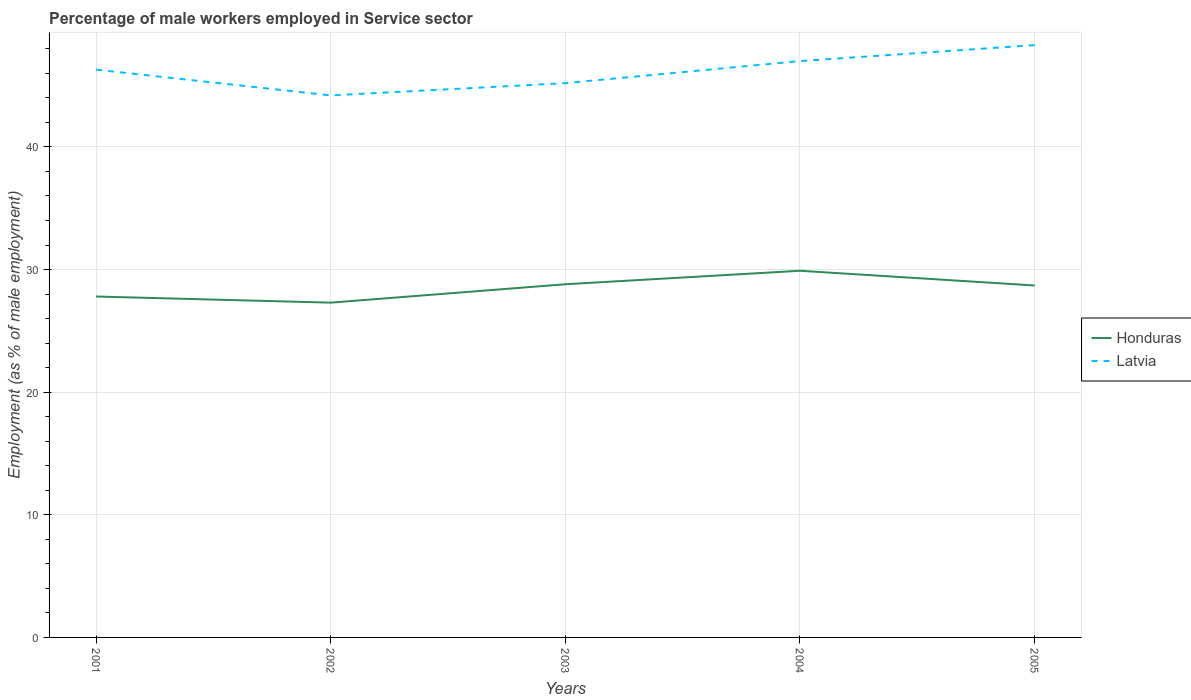How many different coloured lines are there?
Your answer should be compact. 2. Does the line corresponding to Honduras intersect with the line corresponding to Latvia?
Give a very brief answer. No. Is the number of lines equal to the number of legend labels?
Provide a short and direct response. Yes. Across all years, what is the maximum percentage of male workers employed in Service sector in Honduras?
Offer a very short reply. 27.3. In which year was the percentage of male workers employed in Service sector in Latvia maximum?
Your answer should be very brief. 2002. What is the total percentage of male workers employed in Service sector in Latvia in the graph?
Your answer should be compact. 1.1. What is the difference between the highest and the second highest percentage of male workers employed in Service sector in Honduras?
Make the answer very short. 2.6. Is the percentage of male workers employed in Service sector in Honduras strictly greater than the percentage of male workers employed in Service sector in Latvia over the years?
Your answer should be compact. Yes. How many lines are there?
Your answer should be compact. 2. How many years are there in the graph?
Offer a terse response. 5. Are the values on the major ticks of Y-axis written in scientific E-notation?
Your response must be concise. No. Does the graph contain grids?
Your answer should be very brief. Yes. What is the title of the graph?
Give a very brief answer. Percentage of male workers employed in Service sector. Does "Aruba" appear as one of the legend labels in the graph?
Provide a succinct answer. No. What is the label or title of the Y-axis?
Give a very brief answer. Employment (as % of male employment). What is the Employment (as % of male employment) in Honduras in 2001?
Offer a very short reply. 27.8. What is the Employment (as % of male employment) in Latvia in 2001?
Provide a short and direct response. 46.3. What is the Employment (as % of male employment) in Honduras in 2002?
Your answer should be very brief. 27.3. What is the Employment (as % of male employment) in Latvia in 2002?
Make the answer very short. 44.2. What is the Employment (as % of male employment) of Honduras in 2003?
Make the answer very short. 28.8. What is the Employment (as % of male employment) in Latvia in 2003?
Give a very brief answer. 45.2. What is the Employment (as % of male employment) of Honduras in 2004?
Your answer should be very brief. 29.9. What is the Employment (as % of male employment) of Latvia in 2004?
Keep it short and to the point. 47. What is the Employment (as % of male employment) in Honduras in 2005?
Your answer should be very brief. 28.7. What is the Employment (as % of male employment) of Latvia in 2005?
Your response must be concise. 48.3. Across all years, what is the maximum Employment (as % of male employment) in Honduras?
Keep it short and to the point. 29.9. Across all years, what is the maximum Employment (as % of male employment) in Latvia?
Your response must be concise. 48.3. Across all years, what is the minimum Employment (as % of male employment) of Honduras?
Ensure brevity in your answer.  27.3. Across all years, what is the minimum Employment (as % of male employment) of Latvia?
Offer a very short reply. 44.2. What is the total Employment (as % of male employment) in Honduras in the graph?
Make the answer very short. 142.5. What is the total Employment (as % of male employment) of Latvia in the graph?
Provide a succinct answer. 231. What is the difference between the Employment (as % of male employment) in Honduras in 2001 and that in 2002?
Make the answer very short. 0.5. What is the difference between the Employment (as % of male employment) of Latvia in 2001 and that in 2002?
Provide a succinct answer. 2.1. What is the difference between the Employment (as % of male employment) in Honduras in 2001 and that in 2005?
Your response must be concise. -0.9. What is the difference between the Employment (as % of male employment) in Honduras in 2002 and that in 2003?
Give a very brief answer. -1.5. What is the difference between the Employment (as % of male employment) of Latvia in 2002 and that in 2003?
Make the answer very short. -1. What is the difference between the Employment (as % of male employment) of Latvia in 2002 and that in 2004?
Keep it short and to the point. -2.8. What is the difference between the Employment (as % of male employment) of Latvia in 2002 and that in 2005?
Your response must be concise. -4.1. What is the difference between the Employment (as % of male employment) in Honduras in 2003 and that in 2004?
Offer a very short reply. -1.1. What is the difference between the Employment (as % of male employment) of Honduras in 2003 and that in 2005?
Make the answer very short. 0.1. What is the difference between the Employment (as % of male employment) of Honduras in 2004 and that in 2005?
Provide a short and direct response. 1.2. What is the difference between the Employment (as % of male employment) of Latvia in 2004 and that in 2005?
Give a very brief answer. -1.3. What is the difference between the Employment (as % of male employment) in Honduras in 2001 and the Employment (as % of male employment) in Latvia in 2002?
Provide a short and direct response. -16.4. What is the difference between the Employment (as % of male employment) in Honduras in 2001 and the Employment (as % of male employment) in Latvia in 2003?
Your response must be concise. -17.4. What is the difference between the Employment (as % of male employment) of Honduras in 2001 and the Employment (as % of male employment) of Latvia in 2004?
Provide a short and direct response. -19.2. What is the difference between the Employment (as % of male employment) in Honduras in 2001 and the Employment (as % of male employment) in Latvia in 2005?
Ensure brevity in your answer.  -20.5. What is the difference between the Employment (as % of male employment) of Honduras in 2002 and the Employment (as % of male employment) of Latvia in 2003?
Offer a very short reply. -17.9. What is the difference between the Employment (as % of male employment) of Honduras in 2002 and the Employment (as % of male employment) of Latvia in 2004?
Provide a short and direct response. -19.7. What is the difference between the Employment (as % of male employment) in Honduras in 2003 and the Employment (as % of male employment) in Latvia in 2004?
Your answer should be compact. -18.2. What is the difference between the Employment (as % of male employment) in Honduras in 2003 and the Employment (as % of male employment) in Latvia in 2005?
Your answer should be compact. -19.5. What is the difference between the Employment (as % of male employment) of Honduras in 2004 and the Employment (as % of male employment) of Latvia in 2005?
Keep it short and to the point. -18.4. What is the average Employment (as % of male employment) of Honduras per year?
Make the answer very short. 28.5. What is the average Employment (as % of male employment) in Latvia per year?
Ensure brevity in your answer.  46.2. In the year 2001, what is the difference between the Employment (as % of male employment) of Honduras and Employment (as % of male employment) of Latvia?
Offer a very short reply. -18.5. In the year 2002, what is the difference between the Employment (as % of male employment) of Honduras and Employment (as % of male employment) of Latvia?
Offer a terse response. -16.9. In the year 2003, what is the difference between the Employment (as % of male employment) in Honduras and Employment (as % of male employment) in Latvia?
Give a very brief answer. -16.4. In the year 2004, what is the difference between the Employment (as % of male employment) in Honduras and Employment (as % of male employment) in Latvia?
Provide a short and direct response. -17.1. In the year 2005, what is the difference between the Employment (as % of male employment) in Honduras and Employment (as % of male employment) in Latvia?
Offer a terse response. -19.6. What is the ratio of the Employment (as % of male employment) of Honduras in 2001 to that in 2002?
Your answer should be compact. 1.02. What is the ratio of the Employment (as % of male employment) in Latvia in 2001 to that in 2002?
Your response must be concise. 1.05. What is the ratio of the Employment (as % of male employment) in Honduras in 2001 to that in 2003?
Your response must be concise. 0.97. What is the ratio of the Employment (as % of male employment) in Latvia in 2001 to that in 2003?
Provide a succinct answer. 1.02. What is the ratio of the Employment (as % of male employment) of Honduras in 2001 to that in 2004?
Offer a terse response. 0.93. What is the ratio of the Employment (as % of male employment) in Latvia in 2001 to that in 2004?
Your answer should be very brief. 0.99. What is the ratio of the Employment (as % of male employment) of Honduras in 2001 to that in 2005?
Keep it short and to the point. 0.97. What is the ratio of the Employment (as % of male employment) of Latvia in 2001 to that in 2005?
Make the answer very short. 0.96. What is the ratio of the Employment (as % of male employment) of Honduras in 2002 to that in 2003?
Keep it short and to the point. 0.95. What is the ratio of the Employment (as % of male employment) in Latvia in 2002 to that in 2003?
Ensure brevity in your answer.  0.98. What is the ratio of the Employment (as % of male employment) of Honduras in 2002 to that in 2004?
Your answer should be compact. 0.91. What is the ratio of the Employment (as % of male employment) in Latvia in 2002 to that in 2004?
Give a very brief answer. 0.94. What is the ratio of the Employment (as % of male employment) of Honduras in 2002 to that in 2005?
Provide a short and direct response. 0.95. What is the ratio of the Employment (as % of male employment) in Latvia in 2002 to that in 2005?
Offer a terse response. 0.92. What is the ratio of the Employment (as % of male employment) of Honduras in 2003 to that in 2004?
Keep it short and to the point. 0.96. What is the ratio of the Employment (as % of male employment) in Latvia in 2003 to that in 2004?
Ensure brevity in your answer.  0.96. What is the ratio of the Employment (as % of male employment) in Latvia in 2003 to that in 2005?
Ensure brevity in your answer.  0.94. What is the ratio of the Employment (as % of male employment) of Honduras in 2004 to that in 2005?
Make the answer very short. 1.04. What is the ratio of the Employment (as % of male employment) of Latvia in 2004 to that in 2005?
Your answer should be compact. 0.97. What is the difference between the highest and the second highest Employment (as % of male employment) of Honduras?
Your answer should be compact. 1.1. What is the difference between the highest and the second highest Employment (as % of male employment) in Latvia?
Ensure brevity in your answer.  1.3. What is the difference between the highest and the lowest Employment (as % of male employment) of Honduras?
Offer a very short reply. 2.6. 